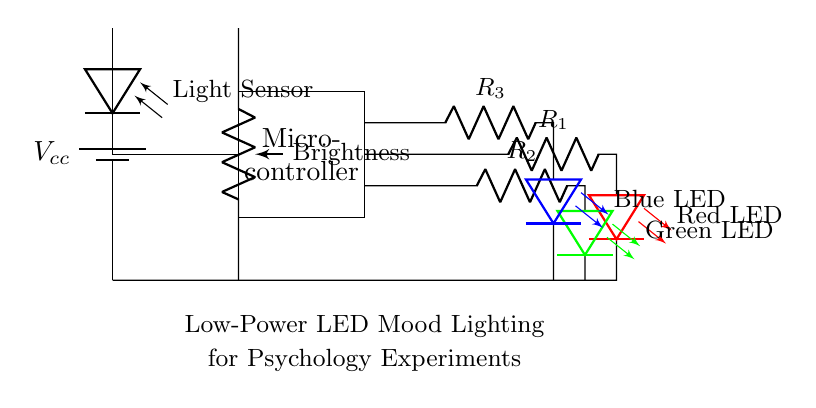What type of power supply is used in this circuit? The circuit uses a battery as indicated by the symbol and label for the power supply.
Answer: Battery What is the function of the potentiometer in this circuit? The potentiometer is labeled as "Brightness," which means it adjusts the brightness of the LEDs, varying the resistance in the circuit.
Answer: Brightness control How many LEDs are present in this circuit? The circuit diagram shows three LEDs (red, green, and blue), each connected with a resistor.
Answer: Three Which LED is connected with the highest resistance? The components connected to the blue LED (associated with resistor R3) are at a higher position than others, indicating the sequential arrangement of increasing resistance; thus, R3 is likely the highest.
Answer: R3 What is the purpose of the light sensor in the circuit? The light sensor is labeled as "Light Sensor," meaning it detects ambient light to potentially influence the circuit's operation, likely adjusting LED brightness based on the environment.
Answer: Light detection How does the microcontroller interact with the LEDs? The microcontroller is responsible for controlling the operation of the LEDs, using its outputs to switch them on or off based on inputs, such as from the light sensor or settings from the potentiometer.
Answer: Controls LEDs What color LED is connected to the lowest resistor value? Since typically each LED will have its distinct resistor value and the green LED is connected to R2 which is visibly situated below the red LED's R1, it's inferred to have the lowest value.
Answer: Green 